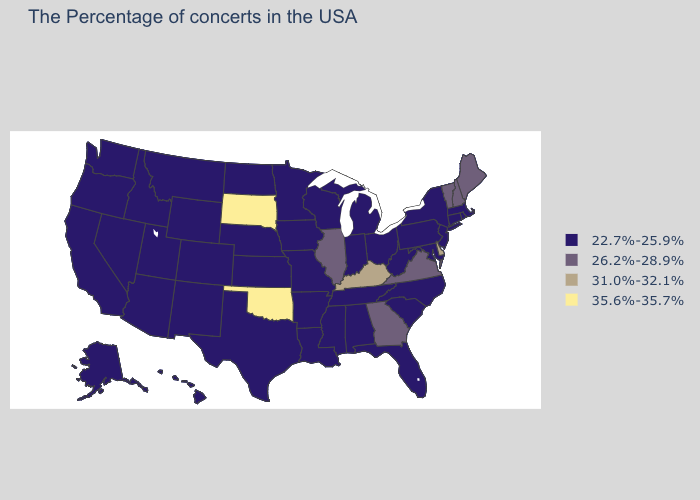What is the highest value in the South ?
Short answer required. 35.6%-35.7%. Name the states that have a value in the range 22.7%-25.9%?
Write a very short answer. Massachusetts, Rhode Island, Connecticut, New York, New Jersey, Maryland, Pennsylvania, North Carolina, South Carolina, West Virginia, Ohio, Florida, Michigan, Indiana, Alabama, Tennessee, Wisconsin, Mississippi, Louisiana, Missouri, Arkansas, Minnesota, Iowa, Kansas, Nebraska, Texas, North Dakota, Wyoming, Colorado, New Mexico, Utah, Montana, Arizona, Idaho, Nevada, California, Washington, Oregon, Alaska, Hawaii. Among the states that border Oregon , which have the highest value?
Be succinct. Idaho, Nevada, California, Washington. Name the states that have a value in the range 35.6%-35.7%?
Short answer required. Oklahoma, South Dakota. What is the value of Oregon?
Concise answer only. 22.7%-25.9%. Does the first symbol in the legend represent the smallest category?
Give a very brief answer. Yes. Name the states that have a value in the range 31.0%-32.1%?
Write a very short answer. Delaware, Kentucky. What is the highest value in the USA?
Concise answer only. 35.6%-35.7%. Name the states that have a value in the range 22.7%-25.9%?
Keep it brief. Massachusetts, Rhode Island, Connecticut, New York, New Jersey, Maryland, Pennsylvania, North Carolina, South Carolina, West Virginia, Ohio, Florida, Michigan, Indiana, Alabama, Tennessee, Wisconsin, Mississippi, Louisiana, Missouri, Arkansas, Minnesota, Iowa, Kansas, Nebraska, Texas, North Dakota, Wyoming, Colorado, New Mexico, Utah, Montana, Arizona, Idaho, Nevada, California, Washington, Oregon, Alaska, Hawaii. Does Tennessee have the same value as New Hampshire?
Quick response, please. No. Which states have the highest value in the USA?
Answer briefly. Oklahoma, South Dakota. What is the value of New Hampshire?
Concise answer only. 26.2%-28.9%. How many symbols are there in the legend?
Be succinct. 4. Name the states that have a value in the range 22.7%-25.9%?
Short answer required. Massachusetts, Rhode Island, Connecticut, New York, New Jersey, Maryland, Pennsylvania, North Carolina, South Carolina, West Virginia, Ohio, Florida, Michigan, Indiana, Alabama, Tennessee, Wisconsin, Mississippi, Louisiana, Missouri, Arkansas, Minnesota, Iowa, Kansas, Nebraska, Texas, North Dakota, Wyoming, Colorado, New Mexico, Utah, Montana, Arizona, Idaho, Nevada, California, Washington, Oregon, Alaska, Hawaii. Name the states that have a value in the range 26.2%-28.9%?
Be succinct. Maine, New Hampshire, Vermont, Virginia, Georgia, Illinois. 